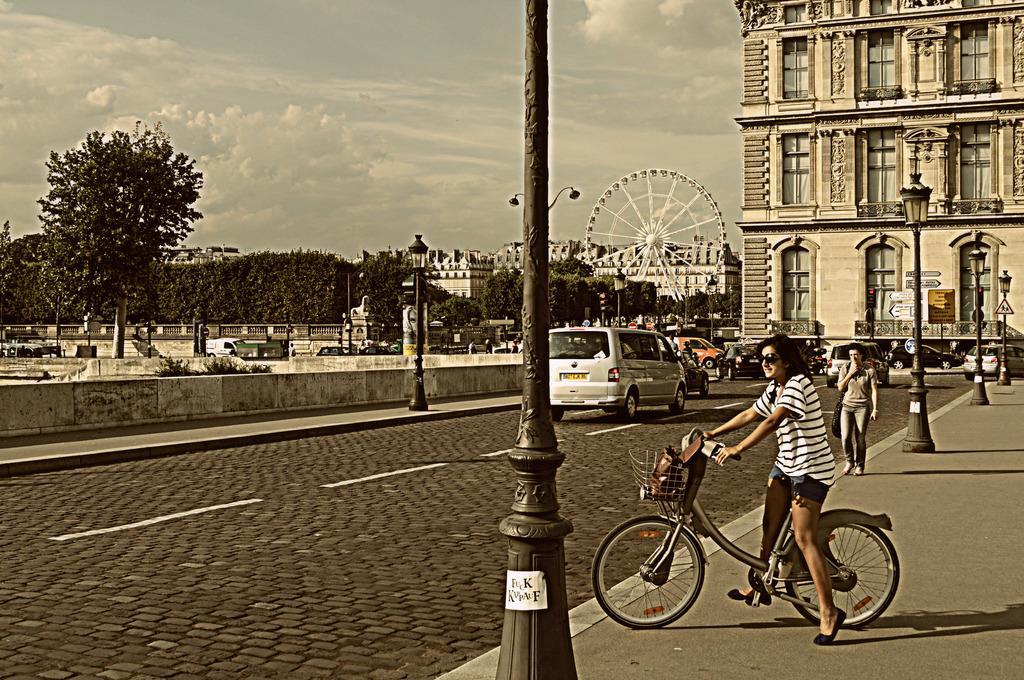Please provide a concise description of this image. in this picture we can see a road and we can also see trees ,here we can see a woman riding a bicycle here we can also see another woman walking,here we can see cars,building,poles was a sunny day. 